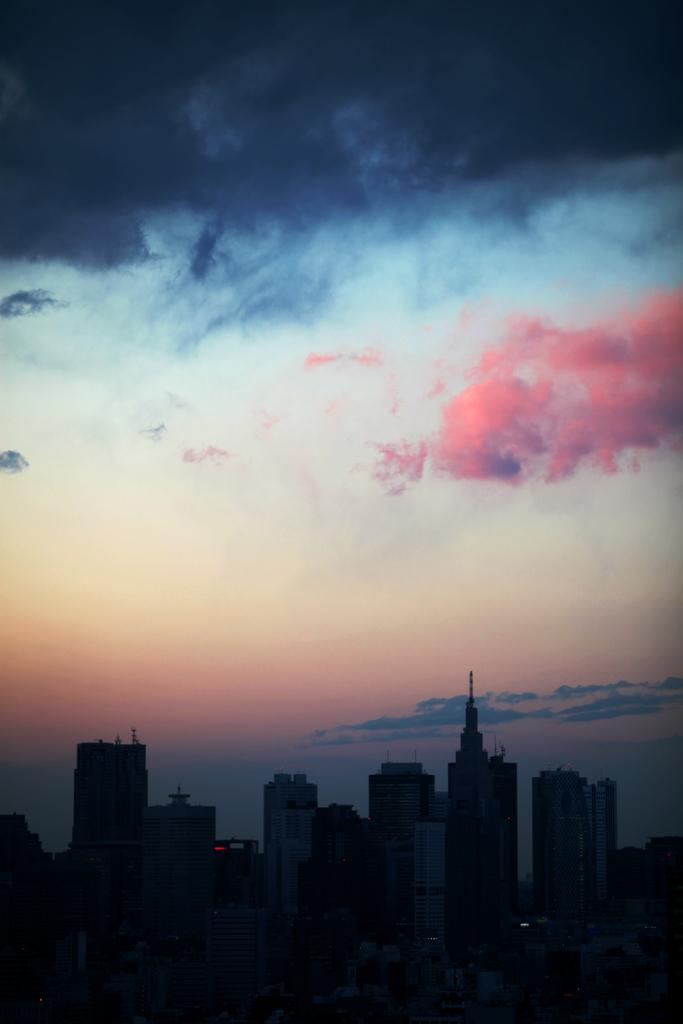What type of structures are located at the bottom of the image? There are buildings at the bottom of the image. What can be seen in the background of the image? The sky is visible in the background of the image. What is present in the sky? Clouds are present in the sky. What type of bell can be heard ringing in the image? There is no bell present in the image, and therefore no sound can be heard. Is there a string attached to the clouds in the image? There is no string attached to the clouds in the image; the clouds are simply floating in the sky. 